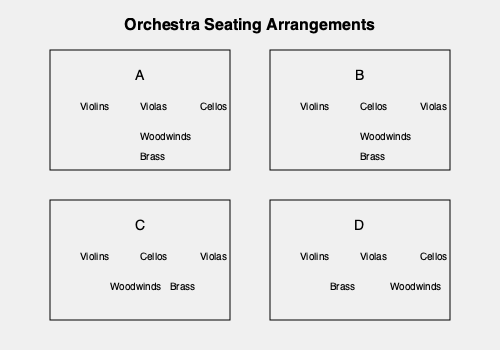Which seating arrangement would be most suitable for a performance of Beethoven's Symphony No. 5, considering the importance of the famous "fate motif" and the need for a powerful, dramatic sound? To determine the most suitable seating arrangement for Beethoven's Symphony No. 5, we need to consider several factors:

1. The "fate motif": This iconic four-note motif is first introduced by the clarinets and strings, particularly the violins. It's crucial for these instruments to be clearly heard.

2. Dramatic sound: Beethoven's 5th Symphony is known for its powerful and dramatic nature, requiring a strong presence from all sections of the orchestra.

3. Balance between sections: The symphony demands a well-balanced sound between strings, woodwinds, and brass.

4. Historical context: While modern orchestras may use various seating arrangements, it's worth considering arrangements that were common during Beethoven's time.

Analyzing the given arrangements:

A: This arrangement places violins together, which is beneficial for the "fate motif." It also follows a more traditional seating plan with strings in front, woodwinds in the middle, and brass at the back. This allows for a natural balance of sound.

B: While this arrangement still has violins in front, it separates them with cellos in the middle. This might slightly dilute the impact of the "fate motif" when played by violins.

C: This arrangement is similar to B but with woodwinds and brass side by side. This might create an imbalance in the powerful brass sections of the symphony.

D: This arrangement places brass in front of woodwinds, which could overpower some of the more delicate woodwind passages in the symphony.

Considering these factors, Arrangement A appears to be the most suitable for Beethoven's 5th Symphony. It allows for a clear projection of the "fate motif" by keeping violins together, maintains a traditional balance between sections, and provides the necessary power and drama required for this iconic work.
Answer: Arrangement A 